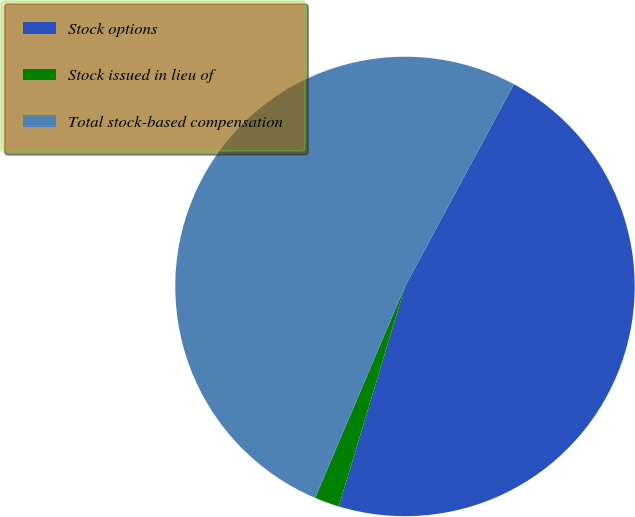Convert chart to OTSL. <chart><loc_0><loc_0><loc_500><loc_500><pie_chart><fcel>Stock options<fcel>Stock issued in lieu of<fcel>Total stock-based compensation<nl><fcel>46.79%<fcel>1.74%<fcel>51.47%<nl></chart> 